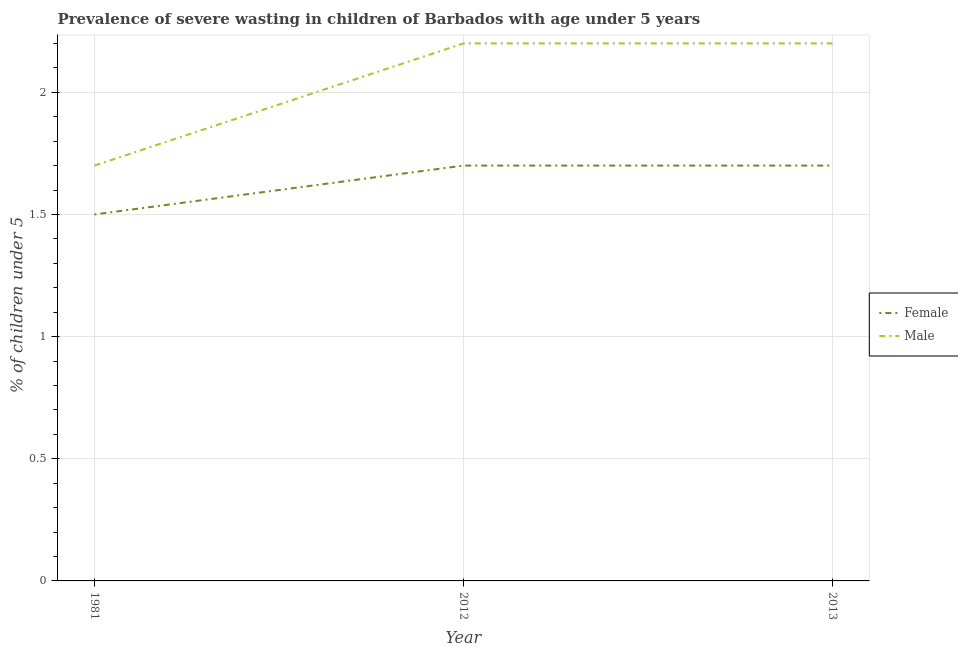Does the line corresponding to percentage of undernourished female children intersect with the line corresponding to percentage of undernourished male children?
Ensure brevity in your answer.  No. Across all years, what is the maximum percentage of undernourished male children?
Ensure brevity in your answer.  2.2. Across all years, what is the minimum percentage of undernourished male children?
Your answer should be compact. 1.7. What is the total percentage of undernourished female children in the graph?
Ensure brevity in your answer.  4.9. What is the difference between the percentage of undernourished female children in 2012 and that in 2013?
Keep it short and to the point. 4.7683720083568915e-8. What is the difference between the percentage of undernourished female children in 1981 and the percentage of undernourished male children in 2013?
Your answer should be compact. -0.7. What is the average percentage of undernourished female children per year?
Give a very brief answer. 1.63. In the year 2013, what is the difference between the percentage of undernourished female children and percentage of undernourished male children?
Your response must be concise. -0.5. In how many years, is the percentage of undernourished female children greater than 0.6 %?
Your response must be concise. 3. What is the ratio of the percentage of undernourished female children in 2012 to that in 2013?
Provide a succinct answer. 1. Is the percentage of undernourished male children in 2012 less than that in 2013?
Give a very brief answer. No. What is the difference between the highest and the second highest percentage of undernourished female children?
Keep it short and to the point. 4.7683720083568915e-8. What is the difference between the highest and the lowest percentage of undernourished male children?
Give a very brief answer. 0.5. In how many years, is the percentage of undernourished female children greater than the average percentage of undernourished female children taken over all years?
Ensure brevity in your answer.  2. Is the sum of the percentage of undernourished female children in 1981 and 2013 greater than the maximum percentage of undernourished male children across all years?
Your answer should be very brief. Yes. Does the percentage of undernourished male children monotonically increase over the years?
Offer a very short reply. No. What is the difference between two consecutive major ticks on the Y-axis?
Your answer should be very brief. 0.5. Where does the legend appear in the graph?
Your answer should be very brief. Center right. How are the legend labels stacked?
Provide a short and direct response. Vertical. What is the title of the graph?
Provide a succinct answer. Prevalence of severe wasting in children of Barbados with age under 5 years. What is the label or title of the Y-axis?
Ensure brevity in your answer.   % of children under 5. What is the  % of children under 5 in Female in 1981?
Keep it short and to the point. 1.5. What is the  % of children under 5 in Male in 1981?
Provide a succinct answer. 1.7. What is the  % of children under 5 in Female in 2012?
Make the answer very short. 1.7. What is the  % of children under 5 of Male in 2012?
Your answer should be very brief. 2.2. What is the  % of children under 5 in Female in 2013?
Keep it short and to the point. 1.7. What is the  % of children under 5 in Male in 2013?
Give a very brief answer. 2.2. Across all years, what is the maximum  % of children under 5 in Female?
Provide a succinct answer. 1.7. Across all years, what is the maximum  % of children under 5 in Male?
Offer a terse response. 2.2. Across all years, what is the minimum  % of children under 5 of Male?
Ensure brevity in your answer.  1.7. What is the total  % of children under 5 in Female in the graph?
Make the answer very short. 4.9. What is the difference between the  % of children under 5 in Female in 1981 and that in 2012?
Your answer should be compact. -0.2. What is the difference between the  % of children under 5 in Male in 1981 and that in 2013?
Your answer should be compact. -0.5. What is the difference between the  % of children under 5 in Male in 2012 and that in 2013?
Your response must be concise. 0. What is the difference between the  % of children under 5 in Female in 1981 and the  % of children under 5 in Male in 2013?
Offer a terse response. -0.7. What is the difference between the  % of children under 5 of Female in 2012 and the  % of children under 5 of Male in 2013?
Make the answer very short. -0.5. What is the average  % of children under 5 in Female per year?
Your response must be concise. 1.63. What is the average  % of children under 5 in Male per year?
Offer a very short reply. 2.03. In the year 1981, what is the difference between the  % of children under 5 of Female and  % of children under 5 of Male?
Your answer should be compact. -0.2. In the year 2013, what is the difference between the  % of children under 5 of Female and  % of children under 5 of Male?
Offer a very short reply. -0.5. What is the ratio of the  % of children under 5 in Female in 1981 to that in 2012?
Your answer should be very brief. 0.88. What is the ratio of the  % of children under 5 of Male in 1981 to that in 2012?
Your answer should be compact. 0.77. What is the ratio of the  % of children under 5 of Female in 1981 to that in 2013?
Provide a short and direct response. 0.88. What is the ratio of the  % of children under 5 of Male in 1981 to that in 2013?
Give a very brief answer. 0.77. What is the ratio of the  % of children under 5 of Female in 2012 to that in 2013?
Provide a succinct answer. 1. What is the difference between the highest and the second highest  % of children under 5 of Female?
Make the answer very short. 0. 